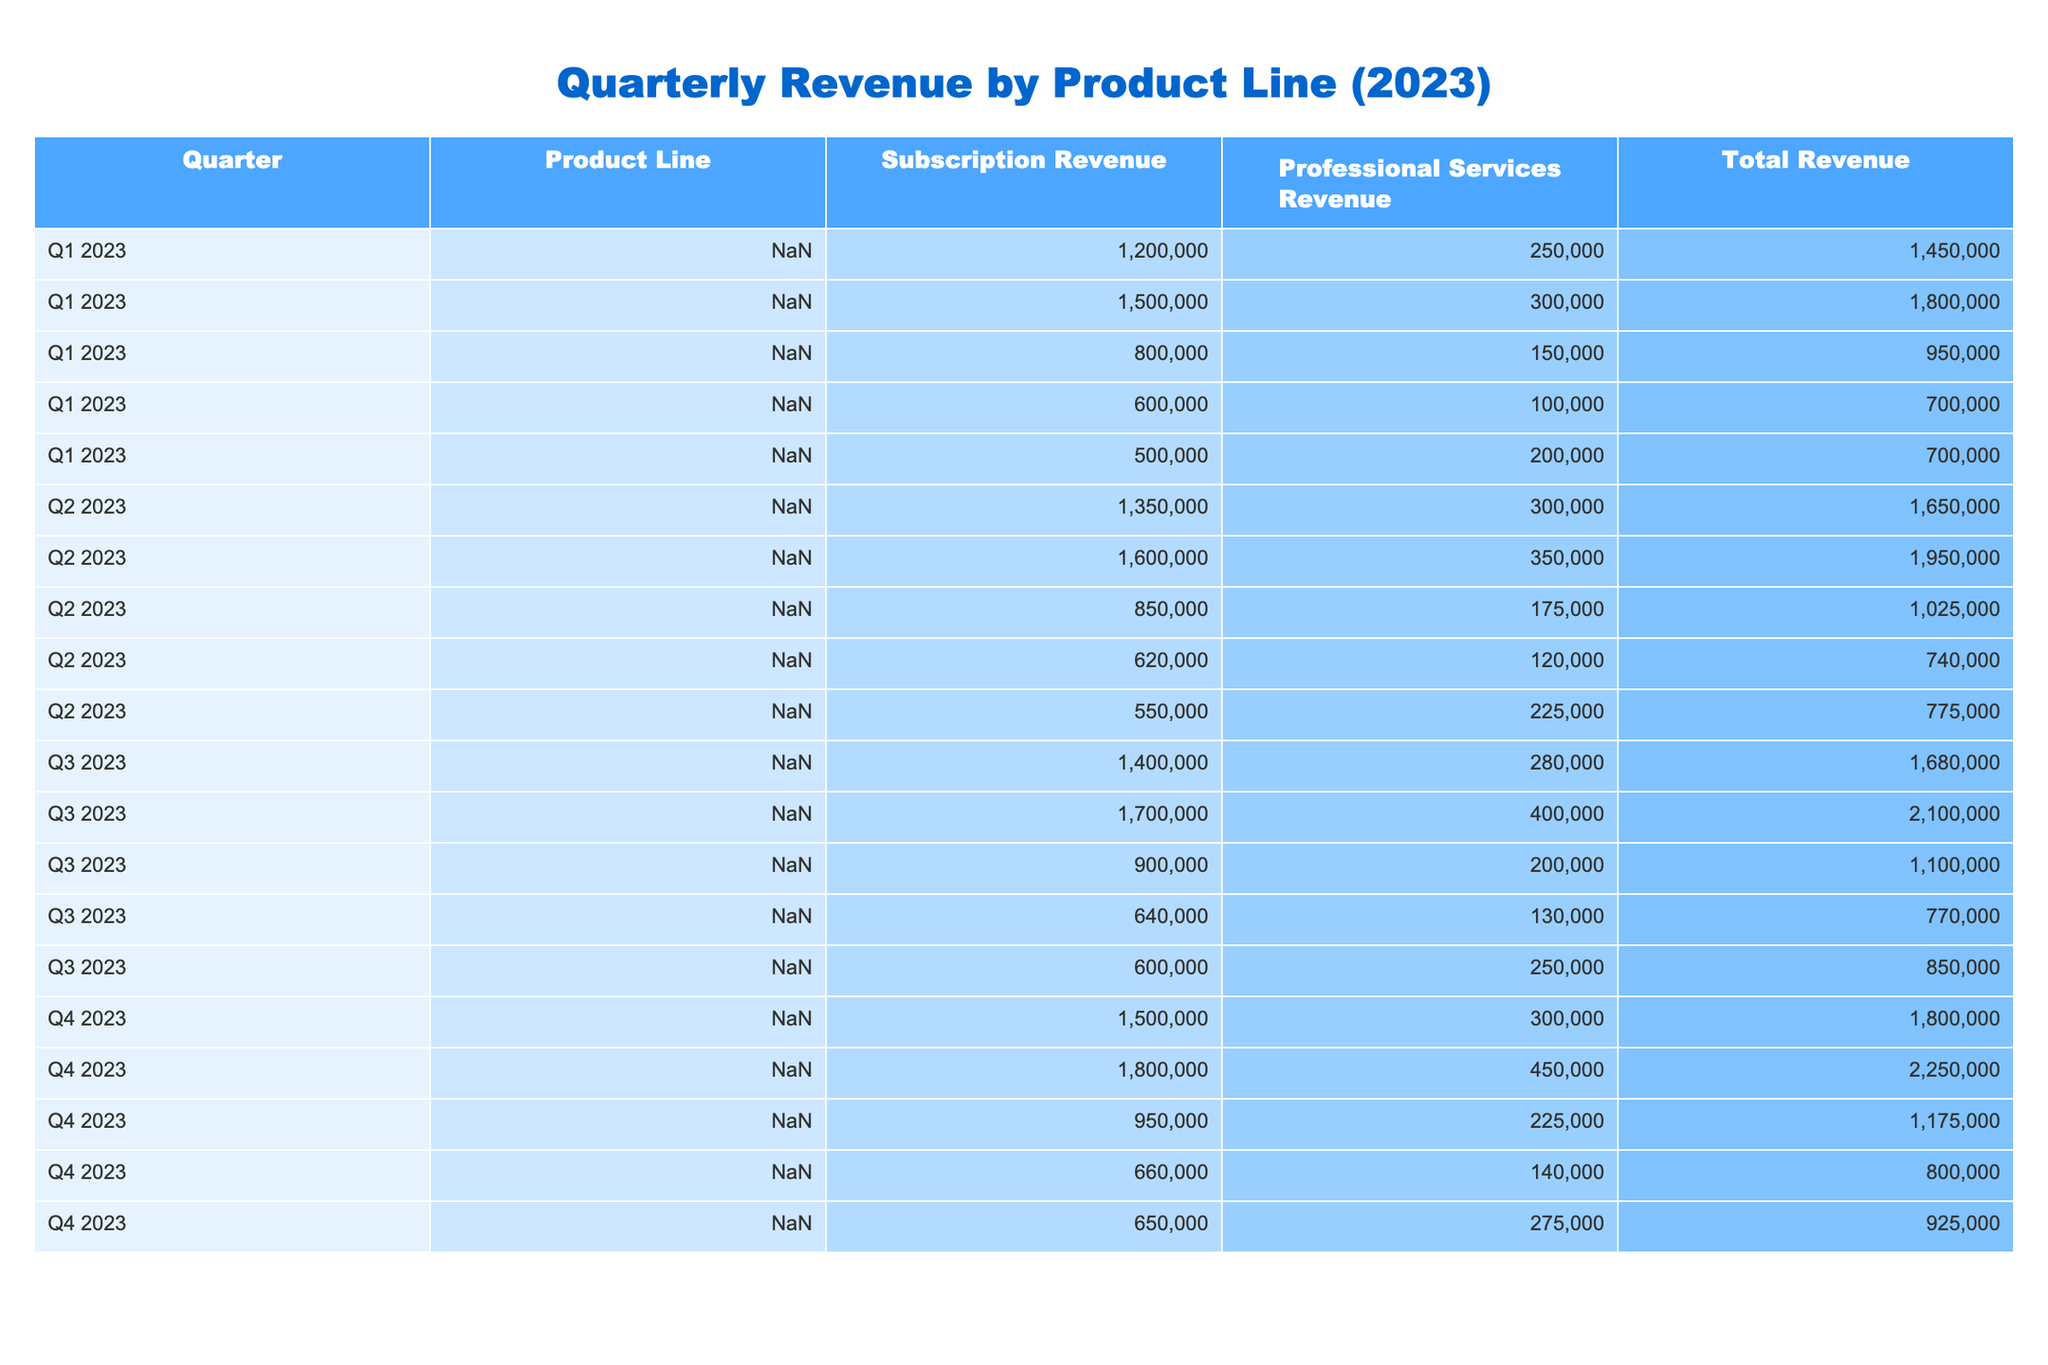What is the total revenue for the Customer Relationship Management product in Q2 2023? In Q2 2023, the total revenue for the Customer Relationship Management product line is listed directly in the table as 1,950,000.
Answer: 1,950,000 Which product line had the highest total revenue in Q3 2023? From the table, the highest total revenue in Q3 2023 belongs to the Customer Relationship Management product line with 2,100,000.
Answer: Customer Relationship Management Calculate the average subscription revenue for the Project Management product line across all four quarters. Adding the subscription revenues for Project Management across all quarters: (800000 + 850000 + 900000 + 950000) = 3500000. Dividing by the number of quarters (4), we get an average of 3500000 / 4 = 875000.
Answer: 875000 Did the total revenue for Collaboration Tools increase from Q1 to Q4 2023? Comparing the total revenues, Q1 2023 has total revenue of 700,000 and Q4 2023 has total revenue of 800,000. Since 800,000 is greater than 700,000, it indicates an increase.
Answer: Yes What is the percentage increase in total revenue from Q1 2023 to Q1 2024 for Marketing Automation? The total revenue for Marketing Automation in Q1 2023 is 1,450,000, and in Q1 2024 it's 1800000. The increase is 1,800,000 - 1,450,000 = 350,000. The percentage increase is (350000 / 1450000) * 100 = 24.14%.
Answer: 24.14% Which product line consistently had the lowest total revenue in all four quarters? By comparing the total revenues of all product lines across each quarter, Collaboration Tools had the lowest total revenue for Q1 (700,000), Q2 (740,000), Q3 (770,000), and Q4 (800,000), consistently being the lowest.
Answer: Collaboration Tools What was the total professional services revenue generated in Q4 2023? In Q4 2023, the professional services revenue for all product lines combined equals: (300000 + 450000 + 225000 + 140000 + 275000) = 1390000.
Answer: 1,390,000 Did the Analytics Platform see a decline in total revenue from Q1 to Q3 2023? The total revenue for Analytics Platform in Q1 2023 is 700,000 and in Q3 2023 is 850,000. Since 850,000 is greater than 700,000, there was no decline between these two quarters.
Answer: No What is the total subscription revenue for all product lines combined in Q2 2023? By summing the subscription revenues for all product lines in Q2 2023: (1,350,000 + 1,600,000 + 850,000 + 620,000 + 550,000) = 4,670,000.
Answer: 4,670,000 Identify the product line with the largest increase in total revenue from Q2 to Q3 2023. Calculating the total revenue for each product line from Q2 to Q3, the increases are: Marketing Automation (1650000 to 1680000, increase of 30,000), Customer Relationship Management (1950000 to 2100000, increase of 150,000), Project Management (1025000 to 1100000, increase of 75,000), Collaboration Tools (740000 to 770000, increase of 30,000), and Analytics Platform (775000 to 850000, increase of 75,000). The largest increase is for Customer Relationship Management by 150,000.
Answer: Customer Relationship Management 